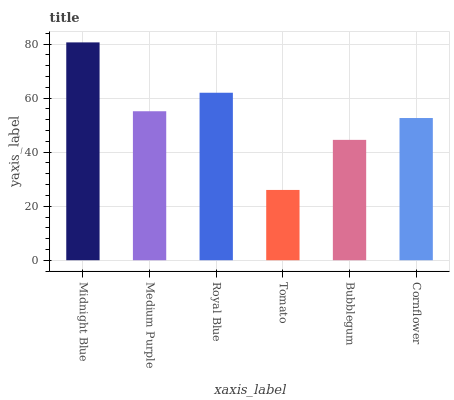Is Medium Purple the minimum?
Answer yes or no. No. Is Medium Purple the maximum?
Answer yes or no. No. Is Midnight Blue greater than Medium Purple?
Answer yes or no. Yes. Is Medium Purple less than Midnight Blue?
Answer yes or no. Yes. Is Medium Purple greater than Midnight Blue?
Answer yes or no. No. Is Midnight Blue less than Medium Purple?
Answer yes or no. No. Is Medium Purple the high median?
Answer yes or no. Yes. Is Cornflower the low median?
Answer yes or no. Yes. Is Midnight Blue the high median?
Answer yes or no. No. Is Tomato the low median?
Answer yes or no. No. 